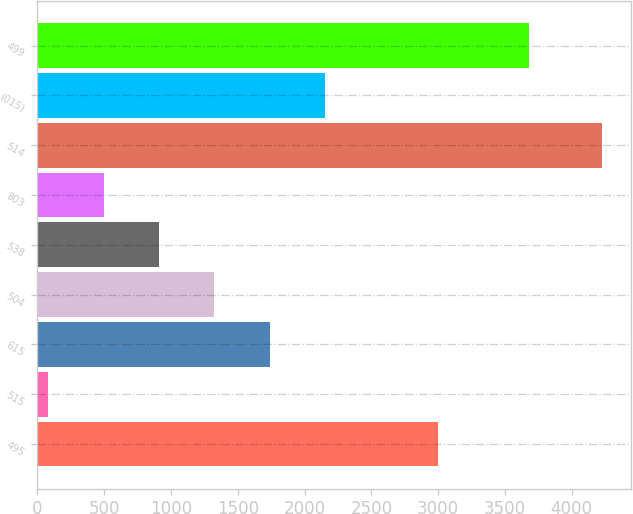<chart> <loc_0><loc_0><loc_500><loc_500><bar_chart><fcel>495<fcel>515<fcel>615<fcel>504<fcel>538<fcel>803<fcel>514<fcel>(015)<fcel>499<nl><fcel>3001<fcel>81<fcel>1740.2<fcel>1325.4<fcel>910.6<fcel>495.8<fcel>4229<fcel>2155<fcel>3680<nl></chart> 